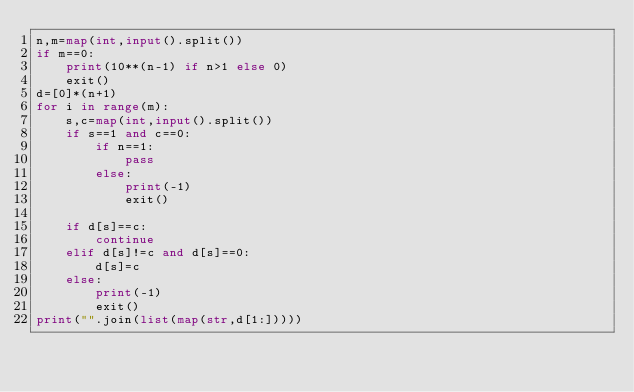Convert code to text. <code><loc_0><loc_0><loc_500><loc_500><_Python_>n,m=map(int,input().split())
if m==0:
    print(10**(n-1) if n>1 else 0)
    exit()
d=[0]*(n+1)
for i in range(m):
    s,c=map(int,input().split())
    if s==1 and c==0:
        if n==1:
            pass
        else:
            print(-1)
            exit()

    if d[s]==c:
        continue
    elif d[s]!=c and d[s]==0:
        d[s]=c
    else:
        print(-1)
        exit()
print("".join(list(map(str,d[1:]))))
</code> 